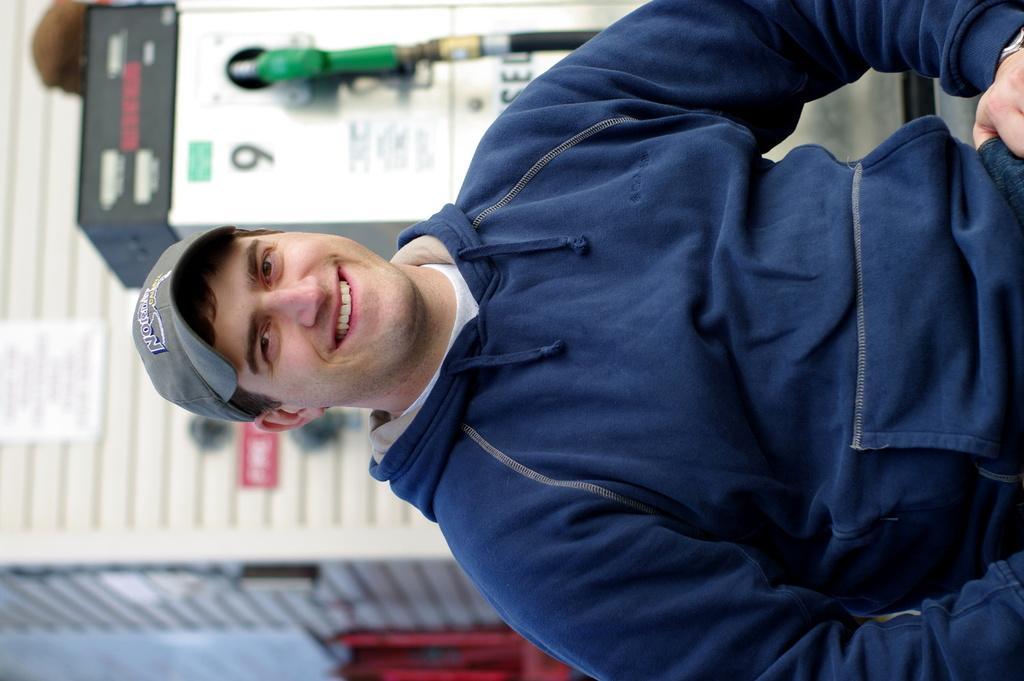In one or two sentences, can you explain what this image depicts? In this image we can see a man smiling and wearing a cap and in the background the place looks like a filling station and the image is blurred. 